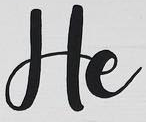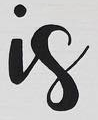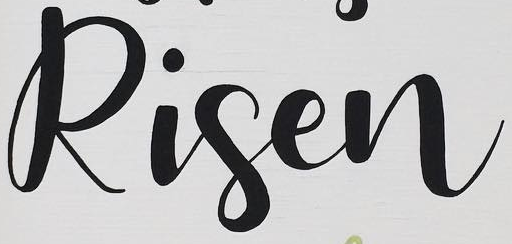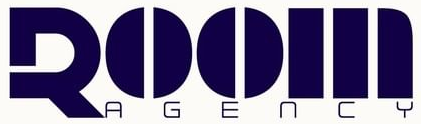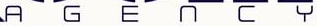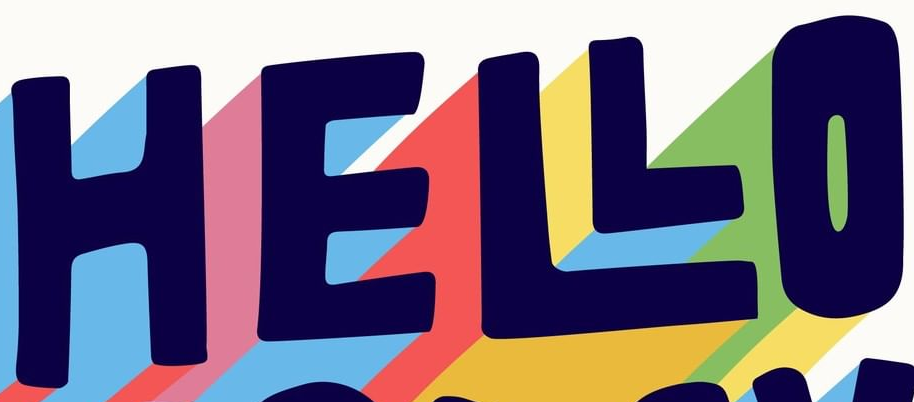What text appears in these images from left to right, separated by a semicolon? He; is; Risen; ROOM; AGENCY; HELLO 